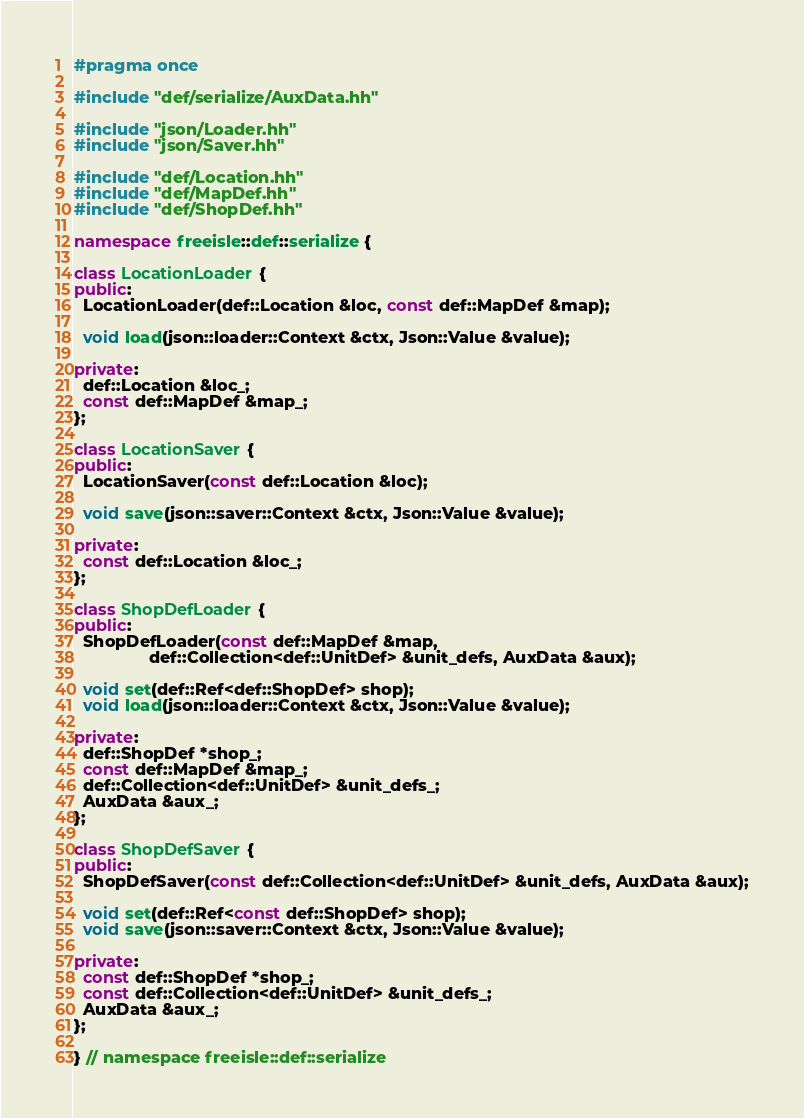Convert code to text. <code><loc_0><loc_0><loc_500><loc_500><_C++_>#pragma once

#include "def/serialize/AuxData.hh"

#include "json/Loader.hh"
#include "json/Saver.hh"

#include "def/Location.hh"
#include "def/MapDef.hh"
#include "def/ShopDef.hh"

namespace freeisle::def::serialize {

class LocationLoader {
public:
  LocationLoader(def::Location &loc, const def::MapDef &map);

  void load(json::loader::Context &ctx, Json::Value &value);

private:
  def::Location &loc_;
  const def::MapDef &map_;
};

class LocationSaver {
public:
  LocationSaver(const def::Location &loc);

  void save(json::saver::Context &ctx, Json::Value &value);

private:
  const def::Location &loc_;
};

class ShopDefLoader {
public:
  ShopDefLoader(const def::MapDef &map,
                def::Collection<def::UnitDef> &unit_defs, AuxData &aux);

  void set(def::Ref<def::ShopDef> shop);
  void load(json::loader::Context &ctx, Json::Value &value);

private:
  def::ShopDef *shop_;
  const def::MapDef &map_;
  def::Collection<def::UnitDef> &unit_defs_;
  AuxData &aux_;
};

class ShopDefSaver {
public:
  ShopDefSaver(const def::Collection<def::UnitDef> &unit_defs, AuxData &aux);

  void set(def::Ref<const def::ShopDef> shop);
  void save(json::saver::Context &ctx, Json::Value &value);

private:
  const def::ShopDef *shop_;
  const def::Collection<def::UnitDef> &unit_defs_;
  AuxData &aux_;
};

} // namespace freeisle::def::serialize
</code> 